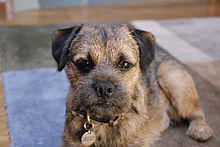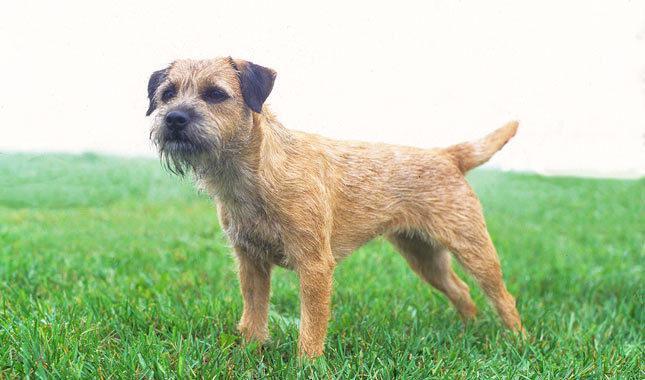The first image is the image on the left, the second image is the image on the right. For the images shown, is this caption "The right image contains exactly one dog standing on grass facing towards the right." true? Answer yes or no. No. The first image is the image on the left, the second image is the image on the right. For the images displayed, is the sentence "The dog on the right is standing on grass, but the dog on the left is not standing." factually correct? Answer yes or no. Yes. 